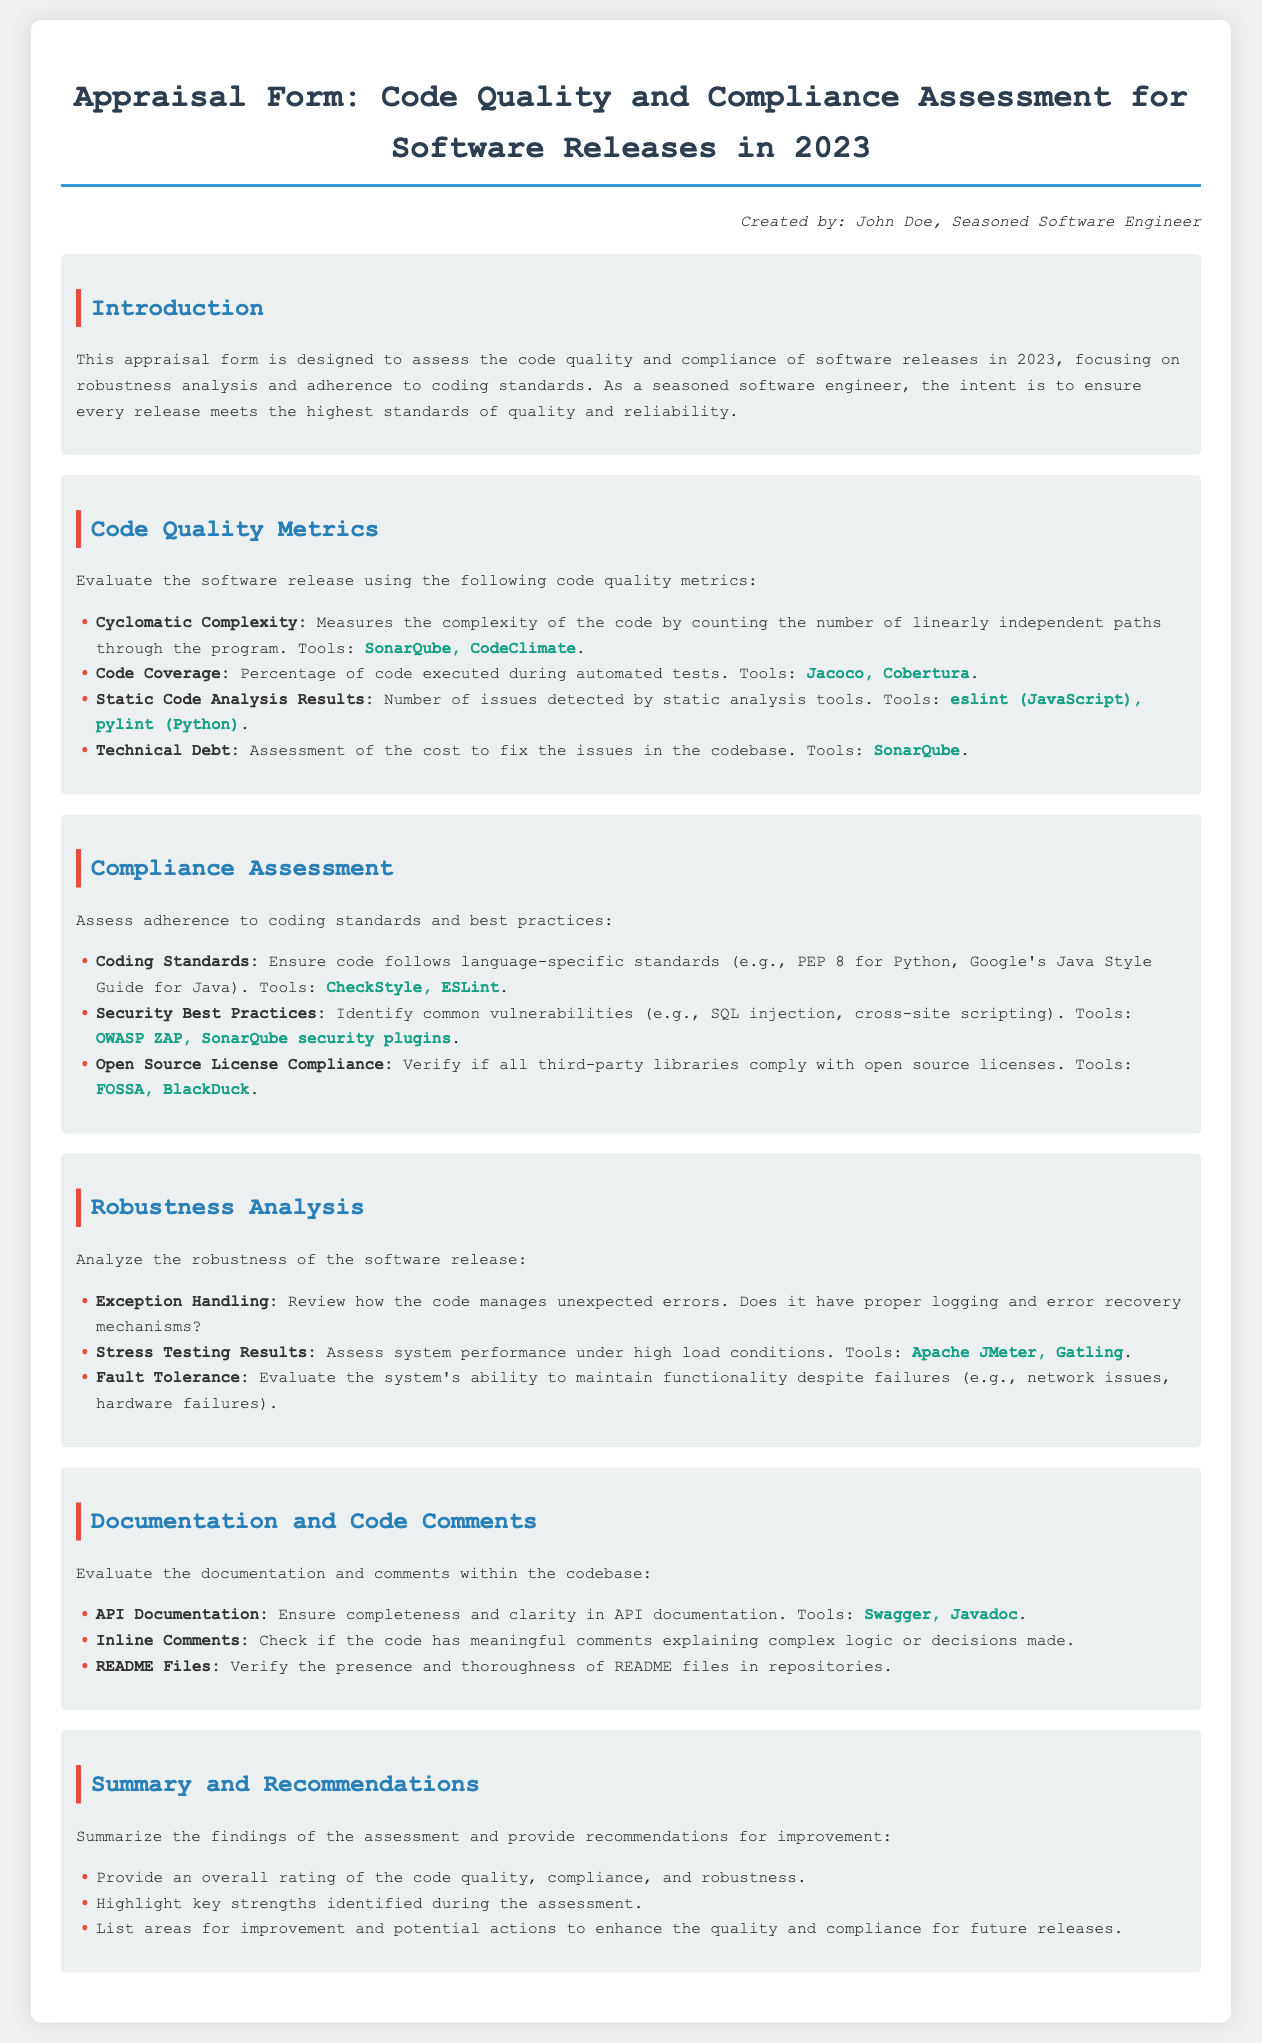What is the title of the document? The title is prominently displayed at the top of the document within the header section.
Answer: Code Quality and Compliance Assessment Who created this document? The creator is mentioned in the footer section of the document.
Answer: John Doe What tools are listed for measuring Cyclomatic Complexity? Tools are specified in the Code Quality Metrics section, referring to specific software.
Answer: SonarQube, CodeClimate What coding standards are referenced for Python? The specific standards relevant to Python are outlined in the Compliance Assessment section.
Answer: PEP 8 Which tools are recommended for assessing Technical Debt? The tools mentioned for this purpose are listed in the Code Quality Metrics section.
Answer: SonarQube What aspect of robustness does Exception Handling focus on? This aspect reviews how the code manages unexpected errors listed in the Robustness Analysis section.
Answer: Management of unexpected errors What document type is this appraisal form categorized as? The document type is defined by its specific title and purpose as outlined in the introduction.
Answer: Appraisal Form How are the Stress Testing Results assessed? The assessment of performance under load is mentioned in the Robustness Analysis section.
Answer: System performance under high load conditions What should be included in API Documentation according to the document? Clarity and completeness are emphasized in the Documentation and Code Comments section.
Answer: Completeness and clarity 